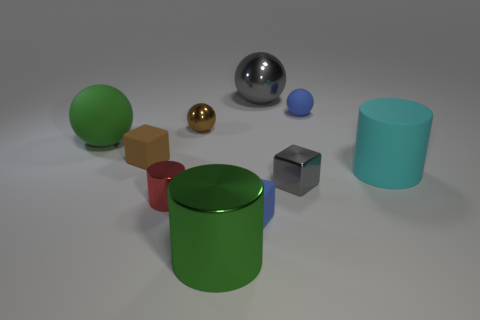Subtract all small blue matte blocks. How many blocks are left? 2 Subtract all blue balls. How many balls are left? 3 Subtract all blocks. How many objects are left? 7 Subtract 1 spheres. How many spheres are left? 3 Subtract all big gray metallic things. Subtract all tiny shiny cylinders. How many objects are left? 8 Add 5 large green matte things. How many large green matte things are left? 6 Add 3 large gray metal balls. How many large gray metal balls exist? 4 Subtract 1 gray blocks. How many objects are left? 9 Subtract all yellow balls. Subtract all gray cylinders. How many balls are left? 4 Subtract all yellow cylinders. How many cyan blocks are left? 0 